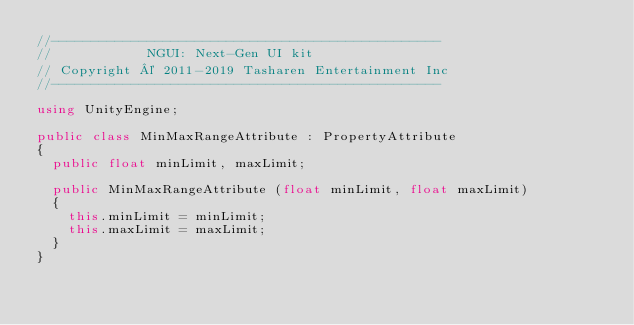Convert code to text. <code><loc_0><loc_0><loc_500><loc_500><_C#_>//-------------------------------------------------
//            NGUI: Next-Gen UI kit
// Copyright © 2011-2019 Tasharen Entertainment Inc
//-------------------------------------------------

using UnityEngine;

public class MinMaxRangeAttribute : PropertyAttribute
{
	public float minLimit, maxLimit;

	public MinMaxRangeAttribute (float minLimit, float maxLimit)
	{
		this.minLimit = minLimit;
		this.maxLimit = maxLimit;
	}
}
</code> 